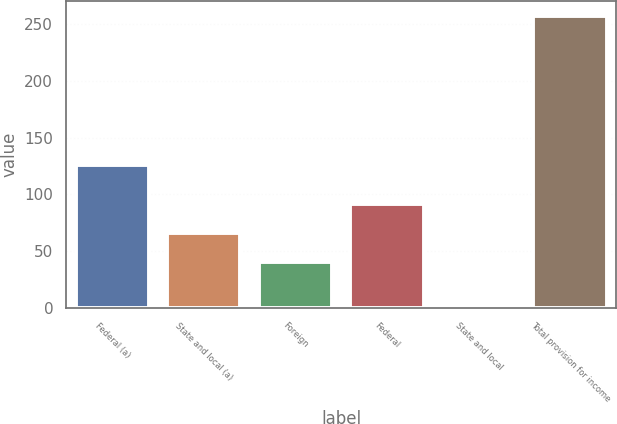Convert chart. <chart><loc_0><loc_0><loc_500><loc_500><bar_chart><fcel>Federal (a)<fcel>State and local (a)<fcel>Foreign<fcel>Federal<fcel>State and local<fcel>Total provision for income<nl><fcel>126.1<fcel>65.76<fcel>40<fcel>91.52<fcel>0.2<fcel>257.8<nl></chart> 